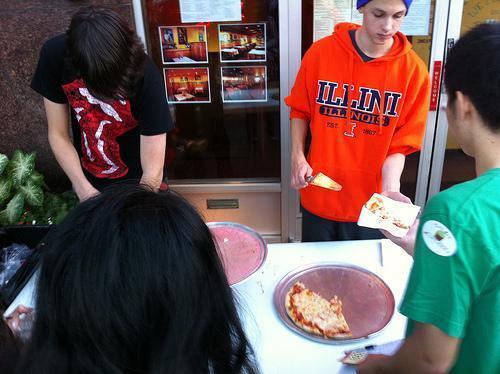How many people are in the picture?
Give a very brief answer. 4. How many slices of pizza are being given to the person in the green shirt?
Give a very brief answer. 1. 